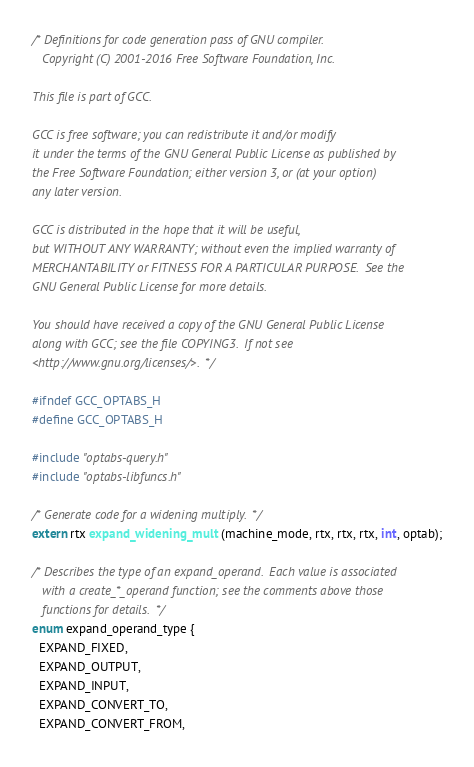Convert code to text. <code><loc_0><loc_0><loc_500><loc_500><_C_>/* Definitions for code generation pass of GNU compiler.
   Copyright (C) 2001-2016 Free Software Foundation, Inc.

This file is part of GCC.

GCC is free software; you can redistribute it and/or modify
it under the terms of the GNU General Public License as published by
the Free Software Foundation; either version 3, or (at your option)
any later version.

GCC is distributed in the hope that it will be useful,
but WITHOUT ANY WARRANTY; without even the implied warranty of
MERCHANTABILITY or FITNESS FOR A PARTICULAR PURPOSE.  See the
GNU General Public License for more details.

You should have received a copy of the GNU General Public License
along with GCC; see the file COPYING3.  If not see
<http://www.gnu.org/licenses/>.  */

#ifndef GCC_OPTABS_H
#define GCC_OPTABS_H

#include "optabs-query.h"
#include "optabs-libfuncs.h"

/* Generate code for a widening multiply.  */
extern rtx expand_widening_mult (machine_mode, rtx, rtx, rtx, int, optab);

/* Describes the type of an expand_operand.  Each value is associated
   with a create_*_operand function; see the comments above those
   functions for details.  */
enum expand_operand_type {
  EXPAND_FIXED,
  EXPAND_OUTPUT,
  EXPAND_INPUT,
  EXPAND_CONVERT_TO,
  EXPAND_CONVERT_FROM,</code> 